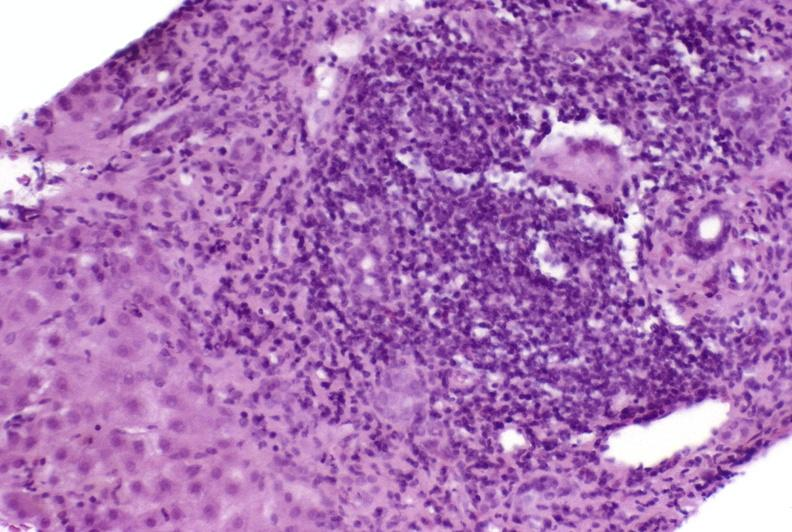s hepatobiliary present?
Answer the question using a single word or phrase. Yes 